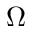<formula> <loc_0><loc_0><loc_500><loc_500>\Omega</formula> 